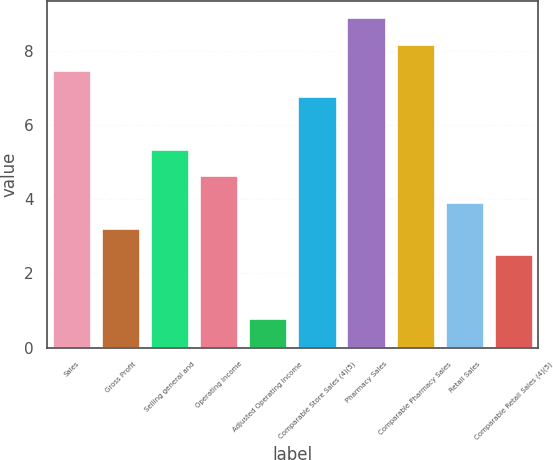<chart> <loc_0><loc_0><loc_500><loc_500><bar_chart><fcel>Sales<fcel>Gross Profit<fcel>Selling general and<fcel>Operating Income<fcel>Adjusted Operating Income<fcel>Comparable Store Sales (4)(5)<fcel>Pharmacy Sales<fcel>Comparable Pharmacy Sales<fcel>Retail Sales<fcel>Comparable Retail Sales (4)(5)<nl><fcel>7.48<fcel>3.22<fcel>5.35<fcel>4.64<fcel>0.8<fcel>6.77<fcel>8.9<fcel>8.19<fcel>3.93<fcel>2.51<nl></chart> 